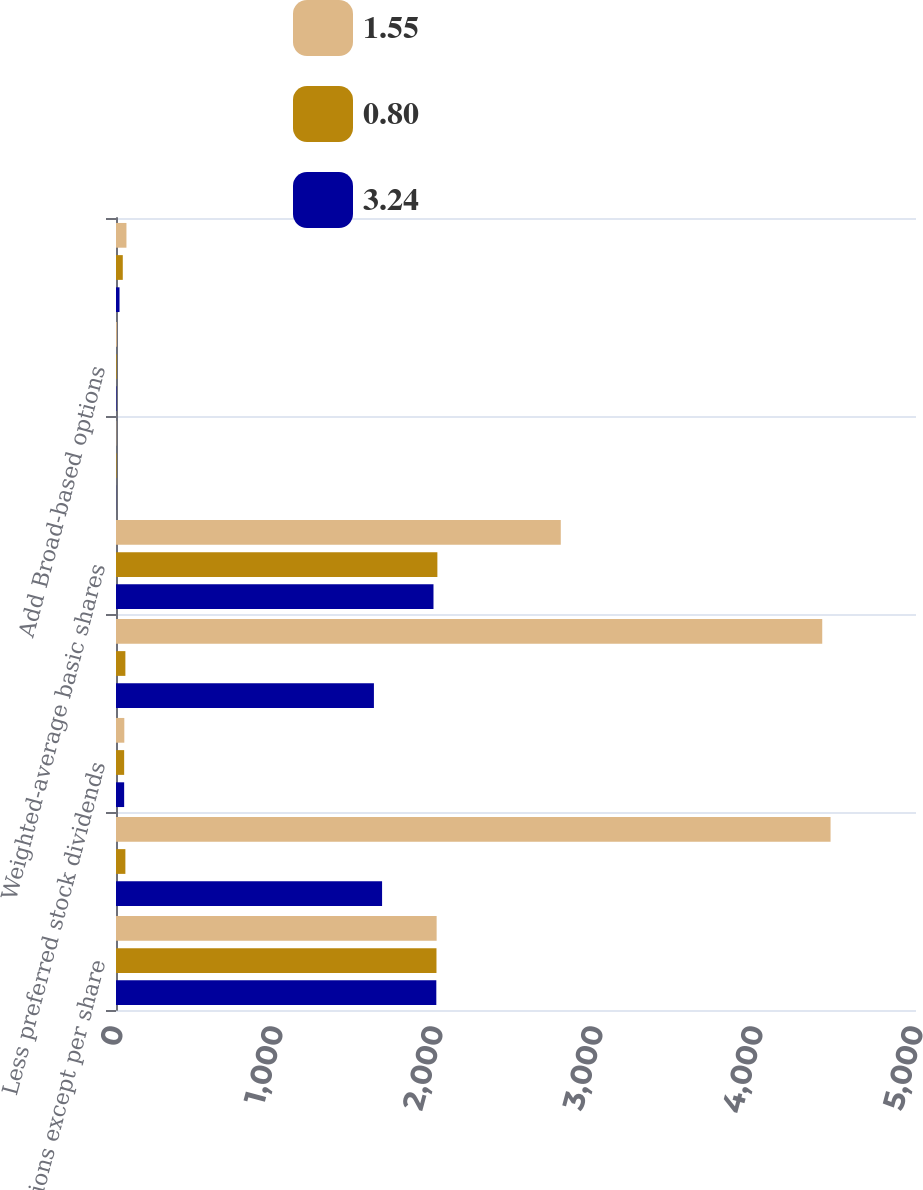<chart> <loc_0><loc_0><loc_500><loc_500><stacked_bar_chart><ecel><fcel>(in millions except per share<fcel>Net income<fcel>Less preferred stock dividends<fcel>Net income applicable to<fcel>Weighted-average basic shares<fcel>Net income per share<fcel>Add Broad-based options<fcel>Key employee options<nl><fcel>1.55<fcel>2004<fcel>4466<fcel>52<fcel>4414<fcel>2779.9<fcel>1.59<fcel>5.4<fcel>65.3<nl><fcel>0.8<fcel>2003<fcel>58.65<fcel>51<fcel>58.65<fcel>2008.6<fcel>3.32<fcel>4.1<fcel>42.4<nl><fcel>3.24<fcel>2002<fcel>1663<fcel>51<fcel>1612<fcel>1984.3<fcel>0.81<fcel>2.8<fcel>22<nl></chart> 